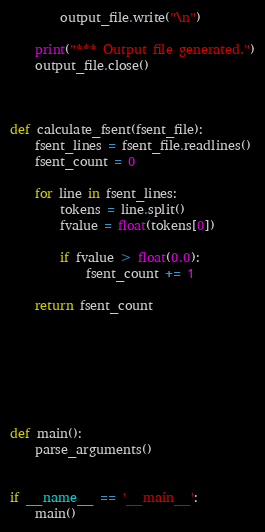<code> <loc_0><loc_0><loc_500><loc_500><_Python_>        output_file.write("\n")

    print("*** Output file generated.")
    output_file.close()



def calculate_fsent(fsent_file):
    fsent_lines = fsent_file.readlines()
    fsent_count = 0

    for line in fsent_lines:
        tokens = line.split()
        fvalue = float(tokens[0])

        if fvalue > float(0.0):
            fsent_count += 1

    return fsent_count







def main():
    parse_arguments()


if __name__ == '__main__':
    main()</code> 